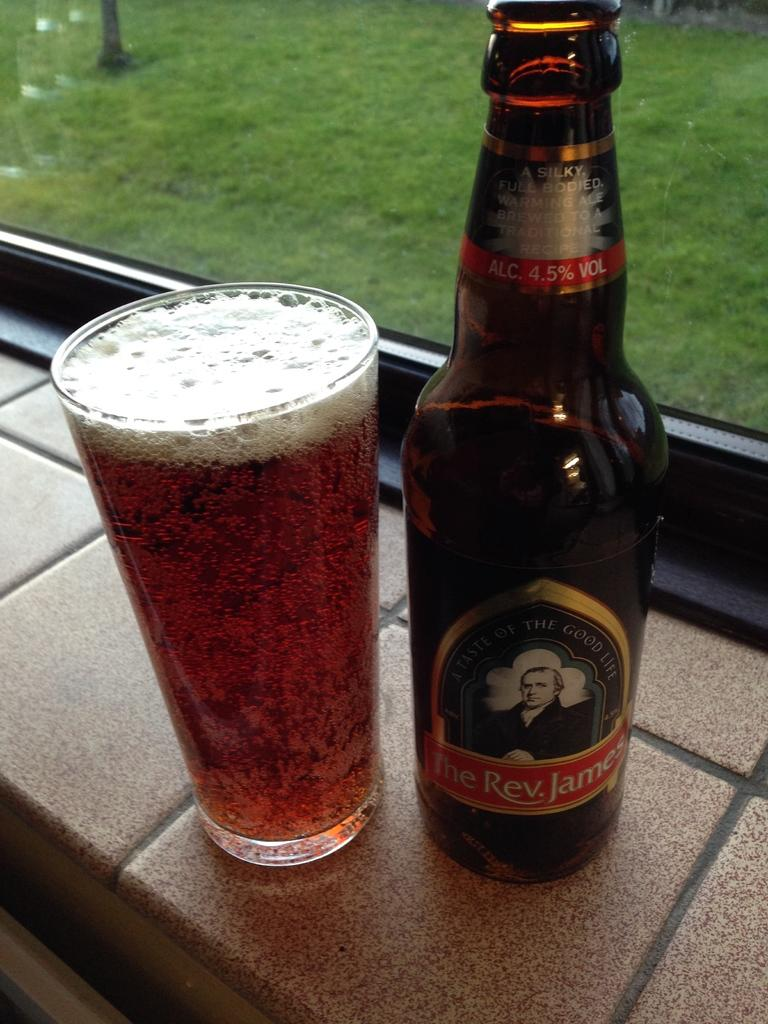<image>
Render a clear and concise summary of the photo. A glass of beer and a beer bottle of The Rev. James. 